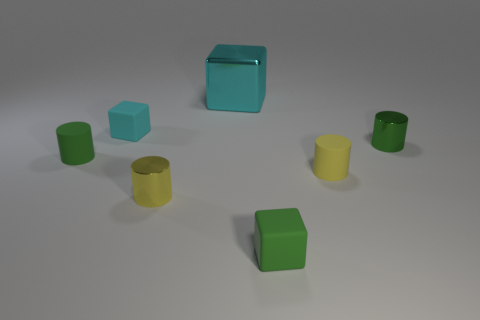There is a small thing that is the same color as the large object; what is it made of?
Provide a succinct answer. Rubber. What size is the green thing that is behind the small green matte block and right of the large cube?
Make the answer very short. Small. What is the shape of the small matte thing that is behind the tiny green cylinder that is to the left of the tiny cyan cube?
Provide a short and direct response. Cube. Are there any other things that are the same shape as the big cyan object?
Offer a very short reply. Yes. Are there the same number of metallic blocks that are on the left side of the big cyan shiny thing and tiny yellow rubber cylinders?
Ensure brevity in your answer.  No. There is a shiny cube; is it the same color as the tiny matte cylinder left of the yellow matte cylinder?
Ensure brevity in your answer.  No. There is a object that is on the left side of the yellow rubber thing and right of the large shiny thing; what color is it?
Provide a short and direct response. Green. How many small metal cylinders are to the left of the small green cylinder that is to the left of the green shiny cylinder?
Your answer should be compact. 0. Is there a tiny cyan thing of the same shape as the tiny green shiny thing?
Make the answer very short. No. Is the number of big brown shiny cylinders the same as the number of cyan blocks?
Keep it short and to the point. No. 